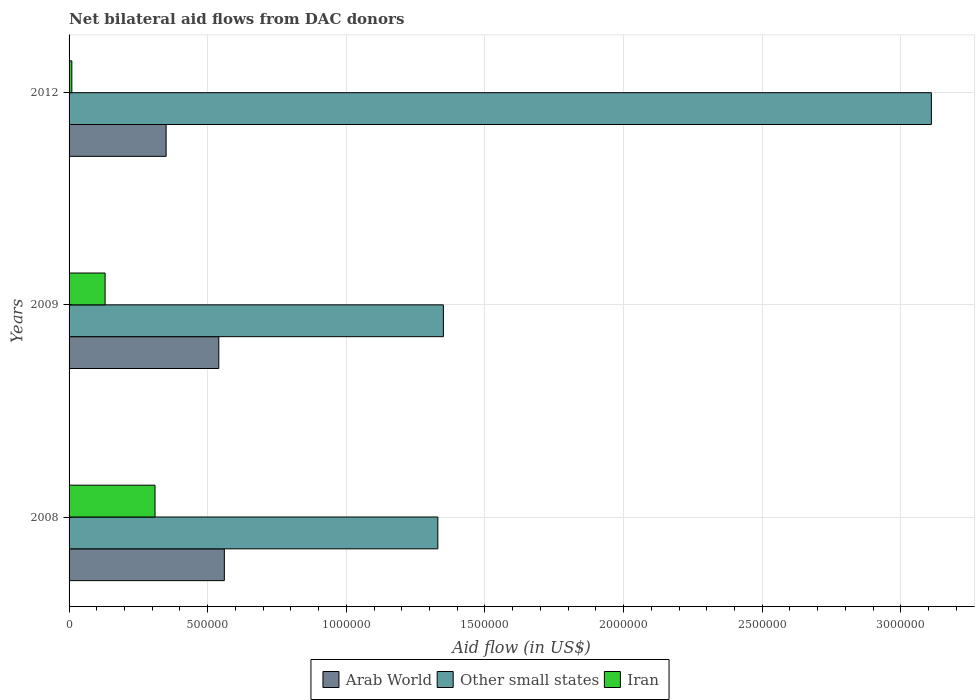How many groups of bars are there?
Give a very brief answer. 3. Across all years, what is the maximum net bilateral aid flow in Other small states?
Offer a very short reply. 3.11e+06. In which year was the net bilateral aid flow in Other small states maximum?
Your answer should be very brief. 2012. What is the total net bilateral aid flow in Arab World in the graph?
Provide a short and direct response. 1.45e+06. What is the difference between the net bilateral aid flow in Other small states in 2009 and that in 2012?
Give a very brief answer. -1.76e+06. What is the difference between the net bilateral aid flow in Arab World in 2008 and the net bilateral aid flow in Other small states in 2012?
Ensure brevity in your answer.  -2.55e+06. What is the average net bilateral aid flow in Arab World per year?
Provide a succinct answer. 4.83e+05. In the year 2009, what is the difference between the net bilateral aid flow in Arab World and net bilateral aid flow in Iran?
Provide a succinct answer. 4.10e+05. In how many years, is the net bilateral aid flow in Arab World greater than 2100000 US$?
Provide a short and direct response. 0. What is the ratio of the net bilateral aid flow in Other small states in 2009 to that in 2012?
Provide a short and direct response. 0.43. Is the net bilateral aid flow in Iran in 2008 less than that in 2009?
Provide a short and direct response. No. Is the difference between the net bilateral aid flow in Arab World in 2008 and 2012 greater than the difference between the net bilateral aid flow in Iran in 2008 and 2012?
Make the answer very short. No. What is the difference between the highest and the second highest net bilateral aid flow in Other small states?
Your response must be concise. 1.76e+06. What does the 1st bar from the top in 2009 represents?
Ensure brevity in your answer.  Iran. What does the 2nd bar from the bottom in 2008 represents?
Your answer should be compact. Other small states. Is it the case that in every year, the sum of the net bilateral aid flow in Arab World and net bilateral aid flow in Other small states is greater than the net bilateral aid flow in Iran?
Ensure brevity in your answer.  Yes. How many bars are there?
Keep it short and to the point. 9. Are all the bars in the graph horizontal?
Keep it short and to the point. Yes. Are the values on the major ticks of X-axis written in scientific E-notation?
Provide a succinct answer. No. Where does the legend appear in the graph?
Provide a succinct answer. Bottom center. How many legend labels are there?
Offer a very short reply. 3. How are the legend labels stacked?
Make the answer very short. Horizontal. What is the title of the graph?
Your answer should be compact. Net bilateral aid flows from DAC donors. Does "High income: OECD" appear as one of the legend labels in the graph?
Give a very brief answer. No. What is the label or title of the X-axis?
Make the answer very short. Aid flow (in US$). What is the label or title of the Y-axis?
Keep it short and to the point. Years. What is the Aid flow (in US$) of Arab World in 2008?
Offer a very short reply. 5.60e+05. What is the Aid flow (in US$) of Other small states in 2008?
Your response must be concise. 1.33e+06. What is the Aid flow (in US$) of Iran in 2008?
Your answer should be compact. 3.10e+05. What is the Aid flow (in US$) of Arab World in 2009?
Keep it short and to the point. 5.40e+05. What is the Aid flow (in US$) in Other small states in 2009?
Make the answer very short. 1.35e+06. What is the Aid flow (in US$) of Other small states in 2012?
Offer a very short reply. 3.11e+06. Across all years, what is the maximum Aid flow (in US$) in Arab World?
Make the answer very short. 5.60e+05. Across all years, what is the maximum Aid flow (in US$) in Other small states?
Your response must be concise. 3.11e+06. Across all years, what is the maximum Aid flow (in US$) of Iran?
Provide a succinct answer. 3.10e+05. Across all years, what is the minimum Aid flow (in US$) of Other small states?
Your answer should be very brief. 1.33e+06. What is the total Aid flow (in US$) of Arab World in the graph?
Your response must be concise. 1.45e+06. What is the total Aid flow (in US$) of Other small states in the graph?
Offer a very short reply. 5.79e+06. What is the difference between the Aid flow (in US$) of Arab World in 2008 and that in 2012?
Your answer should be very brief. 2.10e+05. What is the difference between the Aid flow (in US$) in Other small states in 2008 and that in 2012?
Your answer should be very brief. -1.78e+06. What is the difference between the Aid flow (in US$) of Other small states in 2009 and that in 2012?
Make the answer very short. -1.76e+06. What is the difference between the Aid flow (in US$) of Iran in 2009 and that in 2012?
Your answer should be compact. 1.20e+05. What is the difference between the Aid flow (in US$) of Arab World in 2008 and the Aid flow (in US$) of Other small states in 2009?
Keep it short and to the point. -7.90e+05. What is the difference between the Aid flow (in US$) in Arab World in 2008 and the Aid flow (in US$) in Iran in 2009?
Offer a terse response. 4.30e+05. What is the difference between the Aid flow (in US$) in Other small states in 2008 and the Aid flow (in US$) in Iran in 2009?
Give a very brief answer. 1.20e+06. What is the difference between the Aid flow (in US$) in Arab World in 2008 and the Aid flow (in US$) in Other small states in 2012?
Keep it short and to the point. -2.55e+06. What is the difference between the Aid flow (in US$) in Arab World in 2008 and the Aid flow (in US$) in Iran in 2012?
Make the answer very short. 5.50e+05. What is the difference between the Aid flow (in US$) in Other small states in 2008 and the Aid flow (in US$) in Iran in 2012?
Offer a terse response. 1.32e+06. What is the difference between the Aid flow (in US$) of Arab World in 2009 and the Aid flow (in US$) of Other small states in 2012?
Ensure brevity in your answer.  -2.57e+06. What is the difference between the Aid flow (in US$) of Arab World in 2009 and the Aid flow (in US$) of Iran in 2012?
Provide a short and direct response. 5.30e+05. What is the difference between the Aid flow (in US$) in Other small states in 2009 and the Aid flow (in US$) in Iran in 2012?
Your response must be concise. 1.34e+06. What is the average Aid flow (in US$) in Arab World per year?
Offer a terse response. 4.83e+05. What is the average Aid flow (in US$) in Other small states per year?
Your answer should be very brief. 1.93e+06. In the year 2008, what is the difference between the Aid flow (in US$) of Arab World and Aid flow (in US$) of Other small states?
Ensure brevity in your answer.  -7.70e+05. In the year 2008, what is the difference between the Aid flow (in US$) of Arab World and Aid flow (in US$) of Iran?
Keep it short and to the point. 2.50e+05. In the year 2008, what is the difference between the Aid flow (in US$) of Other small states and Aid flow (in US$) of Iran?
Your response must be concise. 1.02e+06. In the year 2009, what is the difference between the Aid flow (in US$) in Arab World and Aid flow (in US$) in Other small states?
Provide a short and direct response. -8.10e+05. In the year 2009, what is the difference between the Aid flow (in US$) of Arab World and Aid flow (in US$) of Iran?
Make the answer very short. 4.10e+05. In the year 2009, what is the difference between the Aid flow (in US$) of Other small states and Aid flow (in US$) of Iran?
Ensure brevity in your answer.  1.22e+06. In the year 2012, what is the difference between the Aid flow (in US$) in Arab World and Aid flow (in US$) in Other small states?
Offer a terse response. -2.76e+06. In the year 2012, what is the difference between the Aid flow (in US$) of Other small states and Aid flow (in US$) of Iran?
Provide a succinct answer. 3.10e+06. What is the ratio of the Aid flow (in US$) in Other small states in 2008 to that in 2009?
Provide a succinct answer. 0.99. What is the ratio of the Aid flow (in US$) in Iran in 2008 to that in 2009?
Offer a terse response. 2.38. What is the ratio of the Aid flow (in US$) in Arab World in 2008 to that in 2012?
Provide a succinct answer. 1.6. What is the ratio of the Aid flow (in US$) in Other small states in 2008 to that in 2012?
Your response must be concise. 0.43. What is the ratio of the Aid flow (in US$) of Arab World in 2009 to that in 2012?
Ensure brevity in your answer.  1.54. What is the ratio of the Aid flow (in US$) of Other small states in 2009 to that in 2012?
Provide a short and direct response. 0.43. What is the difference between the highest and the second highest Aid flow (in US$) in Other small states?
Offer a very short reply. 1.76e+06. What is the difference between the highest and the second highest Aid flow (in US$) in Iran?
Keep it short and to the point. 1.80e+05. What is the difference between the highest and the lowest Aid flow (in US$) of Other small states?
Your answer should be compact. 1.78e+06. What is the difference between the highest and the lowest Aid flow (in US$) in Iran?
Give a very brief answer. 3.00e+05. 